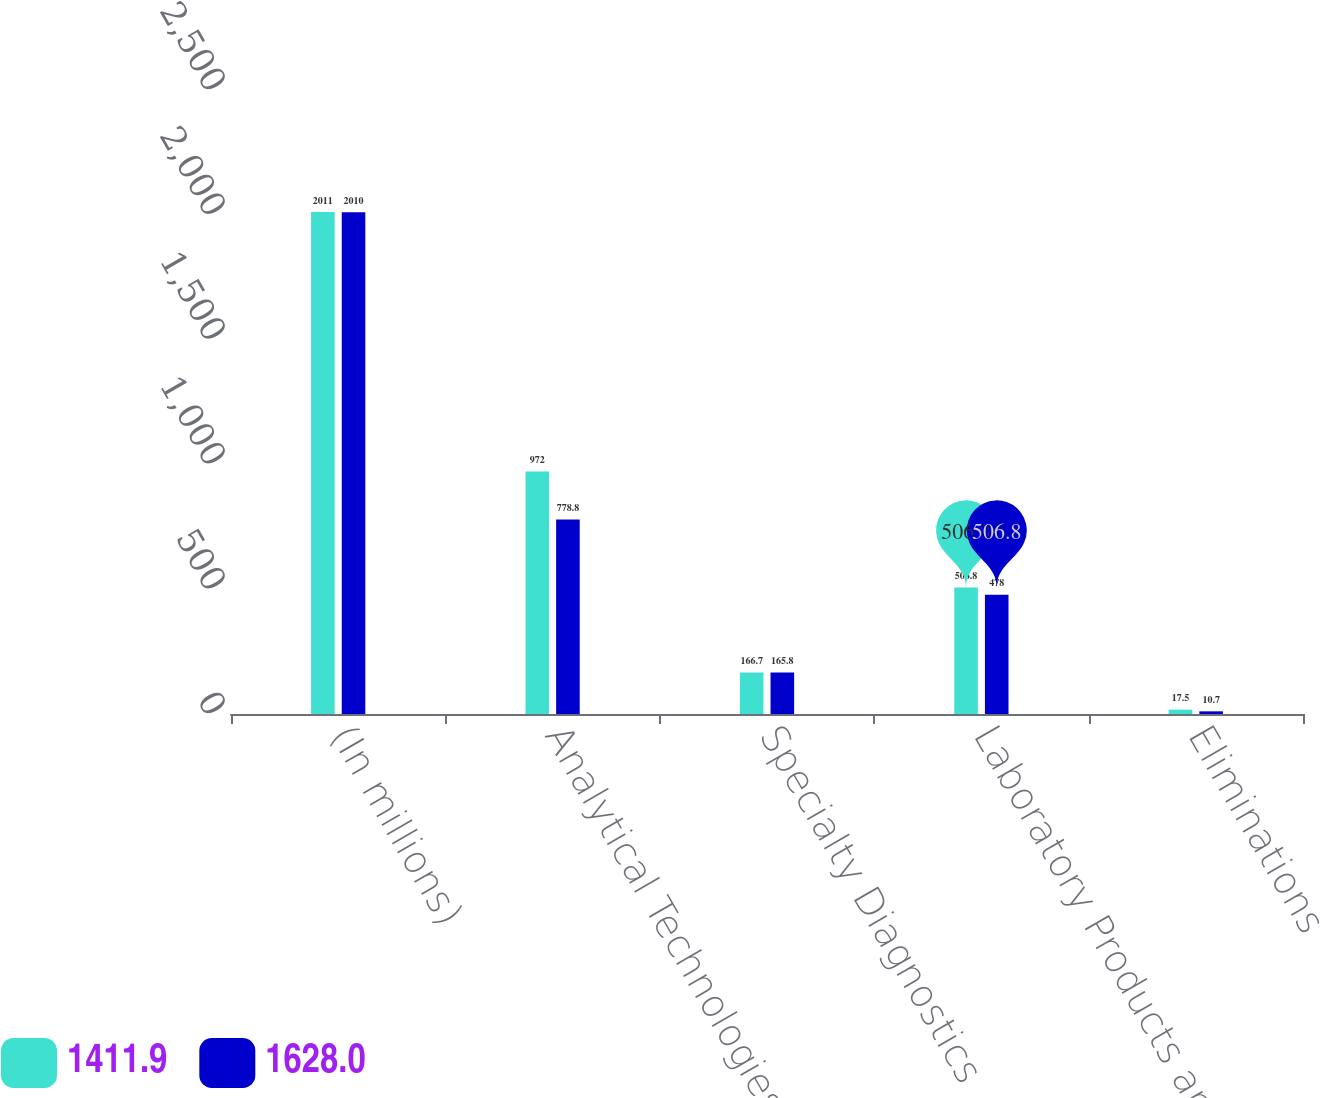<chart> <loc_0><loc_0><loc_500><loc_500><stacked_bar_chart><ecel><fcel>(In millions)<fcel>Analytical Technologies<fcel>Specialty Diagnostics<fcel>Laboratory Products and<fcel>Eliminations<nl><fcel>1411.9<fcel>2011<fcel>972<fcel>166.7<fcel>506.8<fcel>17.5<nl><fcel>1628<fcel>2010<fcel>778.8<fcel>165.8<fcel>478<fcel>10.7<nl></chart> 